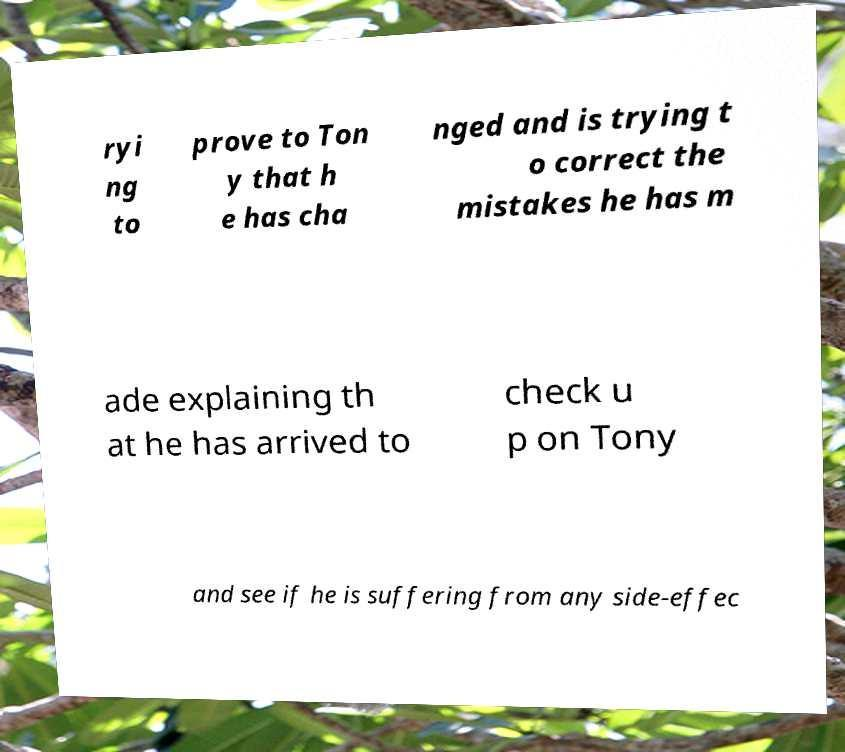Can you read and provide the text displayed in the image?This photo seems to have some interesting text. Can you extract and type it out for me? ryi ng to prove to Ton y that h e has cha nged and is trying t o correct the mistakes he has m ade explaining th at he has arrived to check u p on Tony and see if he is suffering from any side-effec 